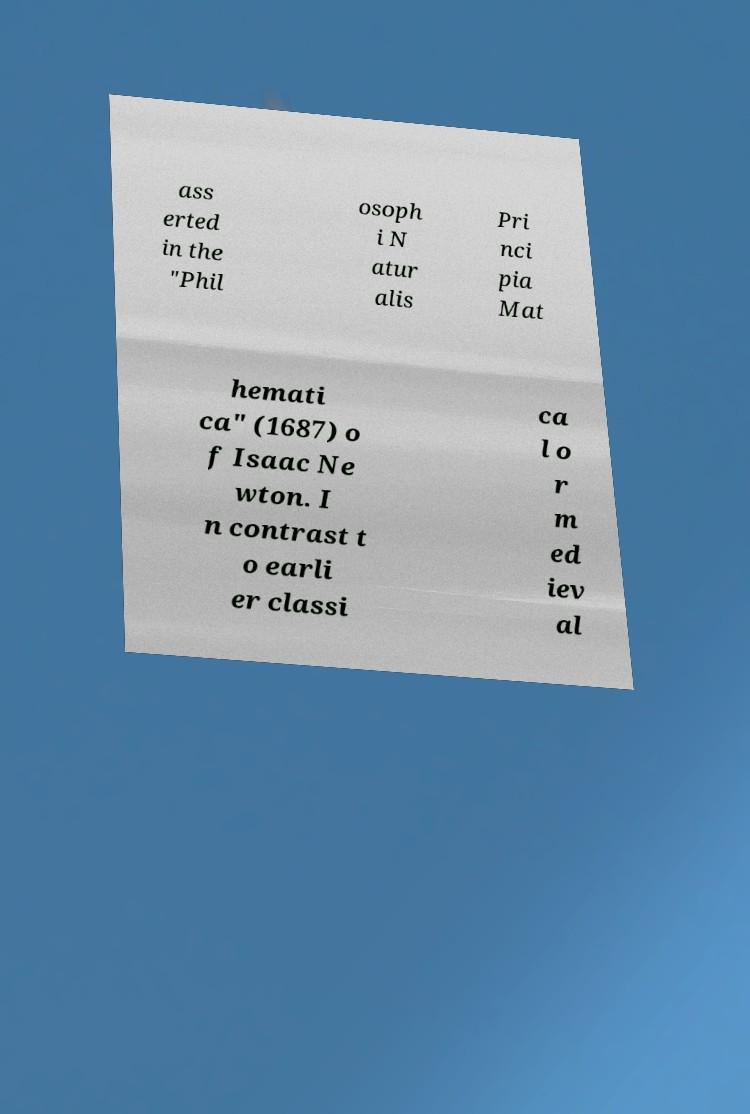Could you assist in decoding the text presented in this image and type it out clearly? ass erted in the "Phil osoph i N atur alis Pri nci pia Mat hemati ca" (1687) o f Isaac Ne wton. I n contrast t o earli er classi ca l o r m ed iev al 